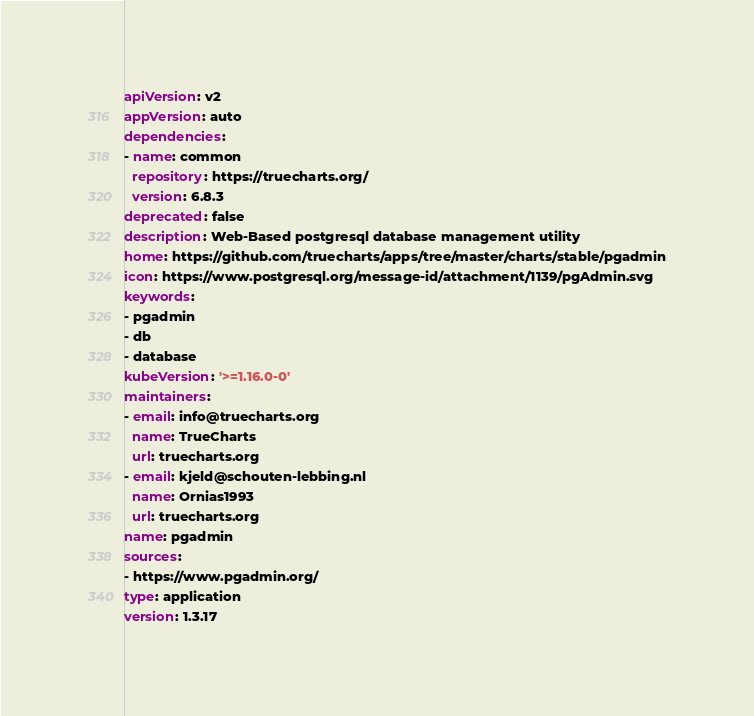Convert code to text. <code><loc_0><loc_0><loc_500><loc_500><_YAML_>apiVersion: v2
appVersion: auto
dependencies:
- name: common
  repository: https://truecharts.org/
  version: 6.8.3
deprecated: false
description: Web-Based postgresql database management utility
home: https://github.com/truecharts/apps/tree/master/charts/stable/pgadmin
icon: https://www.postgresql.org/message-id/attachment/1139/pgAdmin.svg
keywords:
- pgadmin
- db
- database
kubeVersion: '>=1.16.0-0'
maintainers:
- email: info@truecharts.org
  name: TrueCharts
  url: truecharts.org
- email: kjeld@schouten-lebbing.nl
  name: Ornias1993
  url: truecharts.org
name: pgadmin
sources:
- https://www.pgadmin.org/
type: application
version: 1.3.17
</code> 